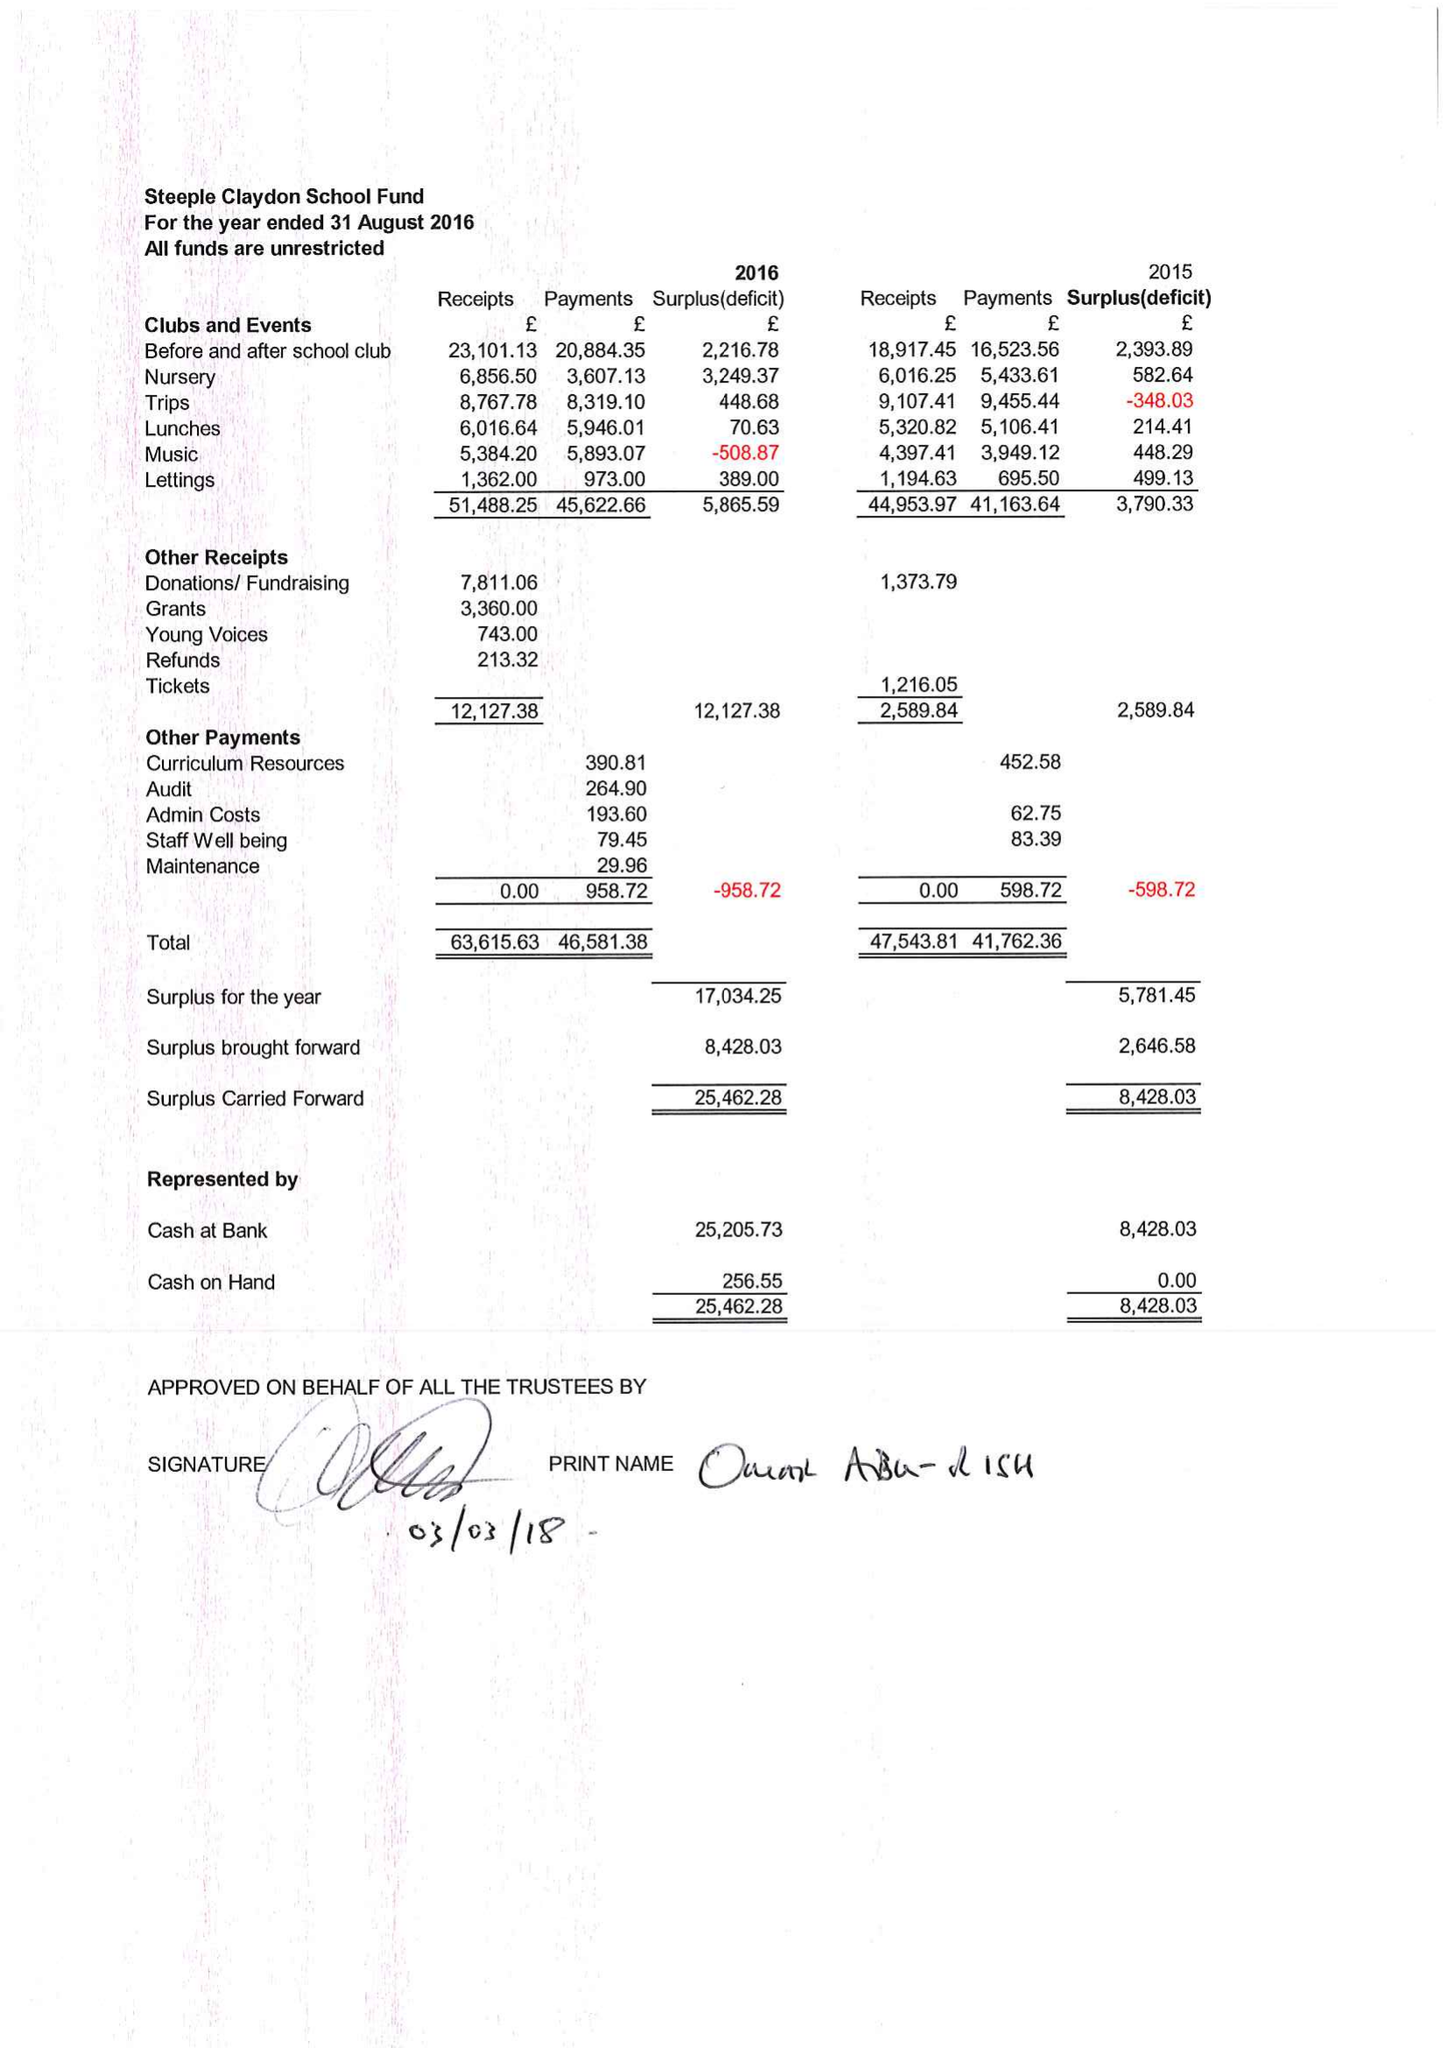What is the value for the address__postcode?
Answer the question using a single word or phrase. MK18 2PA 